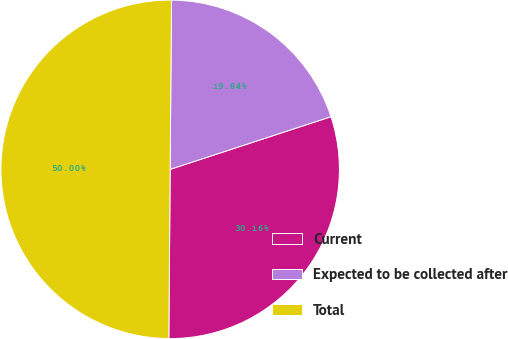Convert chart to OTSL. <chart><loc_0><loc_0><loc_500><loc_500><pie_chart><fcel>Current<fcel>Expected to be collected after<fcel>Total<nl><fcel>30.16%<fcel>19.84%<fcel>50.0%<nl></chart> 